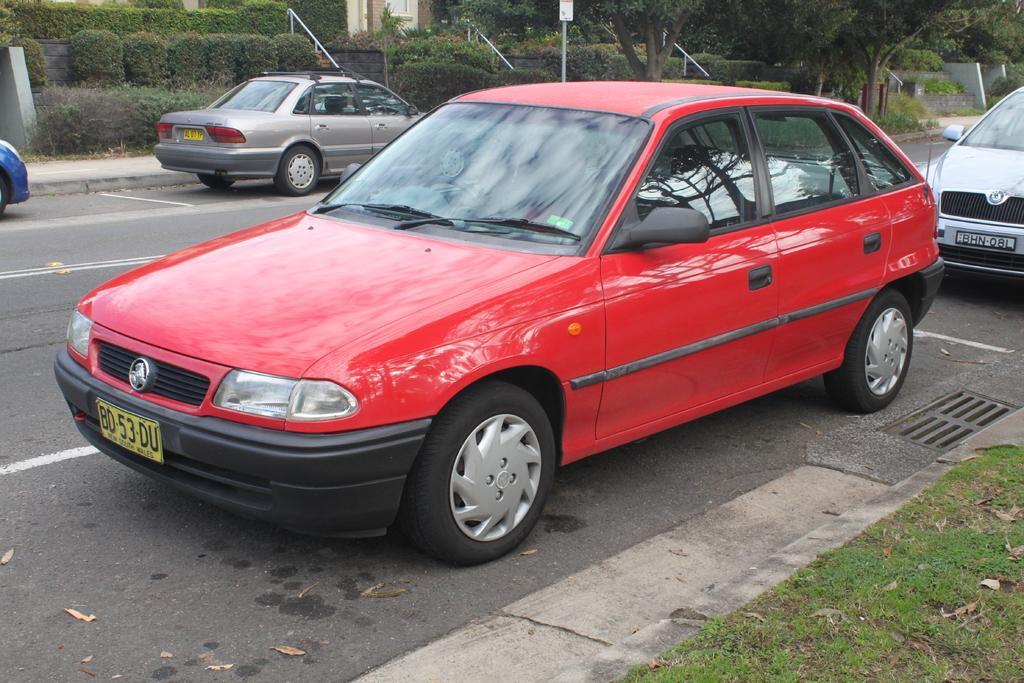How would you summarize this image in a sentence or two? In this picture we can see a red car on the road. We can also see other vehicles on the road. 